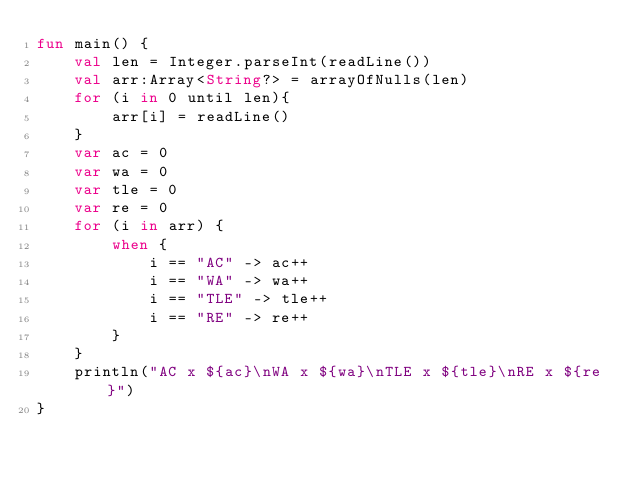<code> <loc_0><loc_0><loc_500><loc_500><_Kotlin_>fun main() {
    val len = Integer.parseInt(readLine())
    val arr:Array<String?> = arrayOfNulls(len)
    for (i in 0 until len){
        arr[i] = readLine()
    }
    var ac = 0
    var wa = 0
    var tle = 0
    var re = 0
    for (i in arr) {
        when {
            i == "AC" -> ac++
            i == "WA" -> wa++
            i == "TLE" -> tle++
            i == "RE" -> re++
        }
    }
    println("AC x ${ac}\nWA x ${wa}\nTLE x ${tle}\nRE x ${re}")
}</code> 